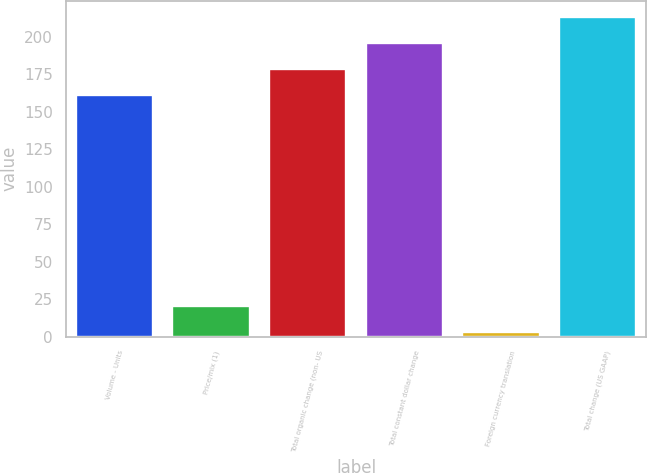Convert chart. <chart><loc_0><loc_0><loc_500><loc_500><bar_chart><fcel>Volume - Units<fcel>Price/mix (1)<fcel>Total organic change (non- US<fcel>Total constant dollar change<fcel>Foreign currency translation<fcel>Total change (US GAAP)<nl><fcel>161.4<fcel>20.33<fcel>178.83<fcel>196.26<fcel>2.9<fcel>213.69<nl></chart> 